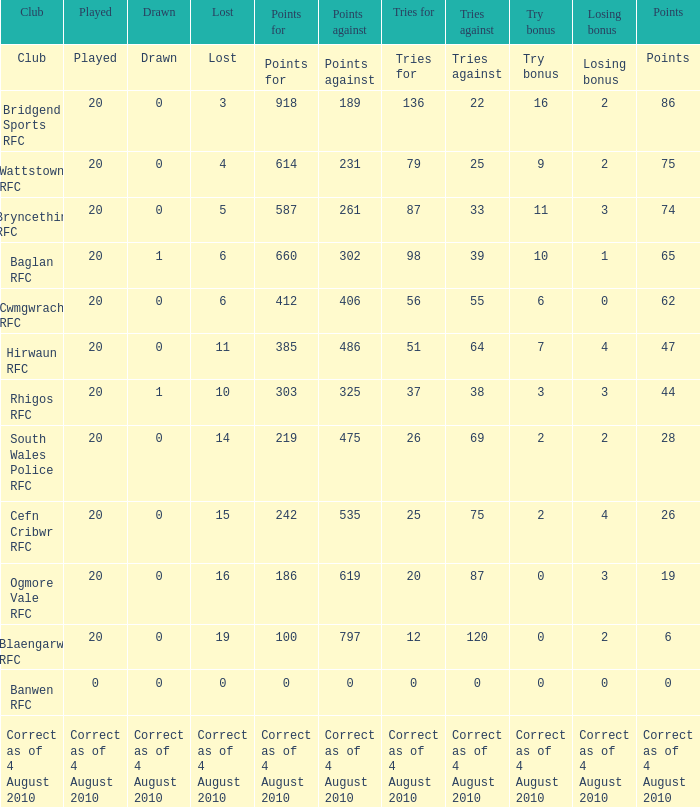What is depicted when the club is hirwaun rfc? 0.0. 